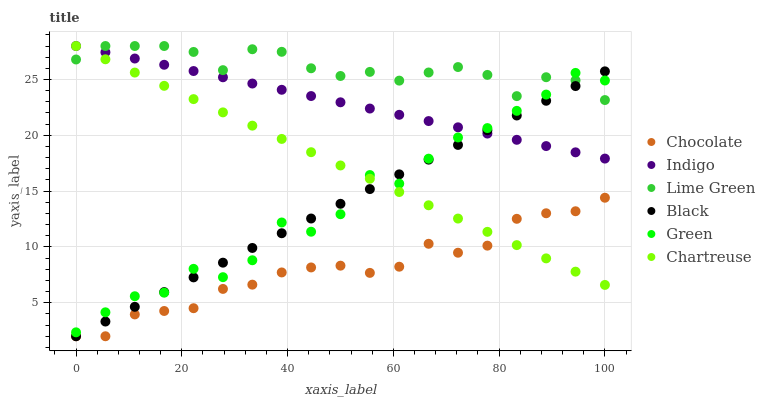Does Chocolate have the minimum area under the curve?
Answer yes or no. Yes. Does Lime Green have the maximum area under the curve?
Answer yes or no. Yes. Does Chartreuse have the minimum area under the curve?
Answer yes or no. No. Does Chartreuse have the maximum area under the curve?
Answer yes or no. No. Is Black the smoothest?
Answer yes or no. Yes. Is Green the roughest?
Answer yes or no. Yes. Is Chocolate the smoothest?
Answer yes or no. No. Is Chocolate the roughest?
Answer yes or no. No. Does Chocolate have the lowest value?
Answer yes or no. Yes. Does Chartreuse have the lowest value?
Answer yes or no. No. Does Lime Green have the highest value?
Answer yes or no. Yes. Does Chocolate have the highest value?
Answer yes or no. No. Is Chocolate less than Green?
Answer yes or no. Yes. Is Green greater than Chocolate?
Answer yes or no. Yes. Does Indigo intersect Chartreuse?
Answer yes or no. Yes. Is Indigo less than Chartreuse?
Answer yes or no. No. Is Indigo greater than Chartreuse?
Answer yes or no. No. Does Chocolate intersect Green?
Answer yes or no. No. 